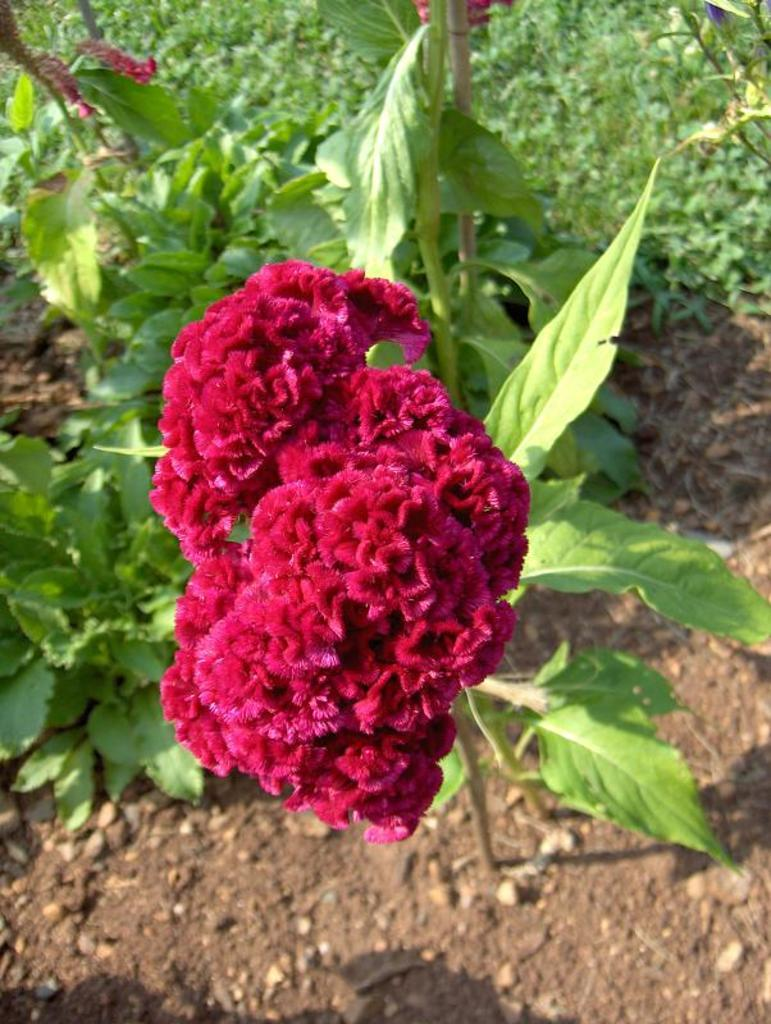What is the main subject of the image? The main subject of the image is a bunch of flowers. Where are the flowers attached? The flowers are attached to a plant. What else can be observed about the plant? The plant has leaves. What can be seen on the floor in the image? There is soil visible on the floor. What is present in the background of the image? There are other plants in the background of the image. What type of fiction is being read by the police officer in the image? There is no police officer or fiction book present in the image. How many plantations are visible in the image? There are no plantations visible in the image; it features a bunch of flowers attached to a plant with leaves. 